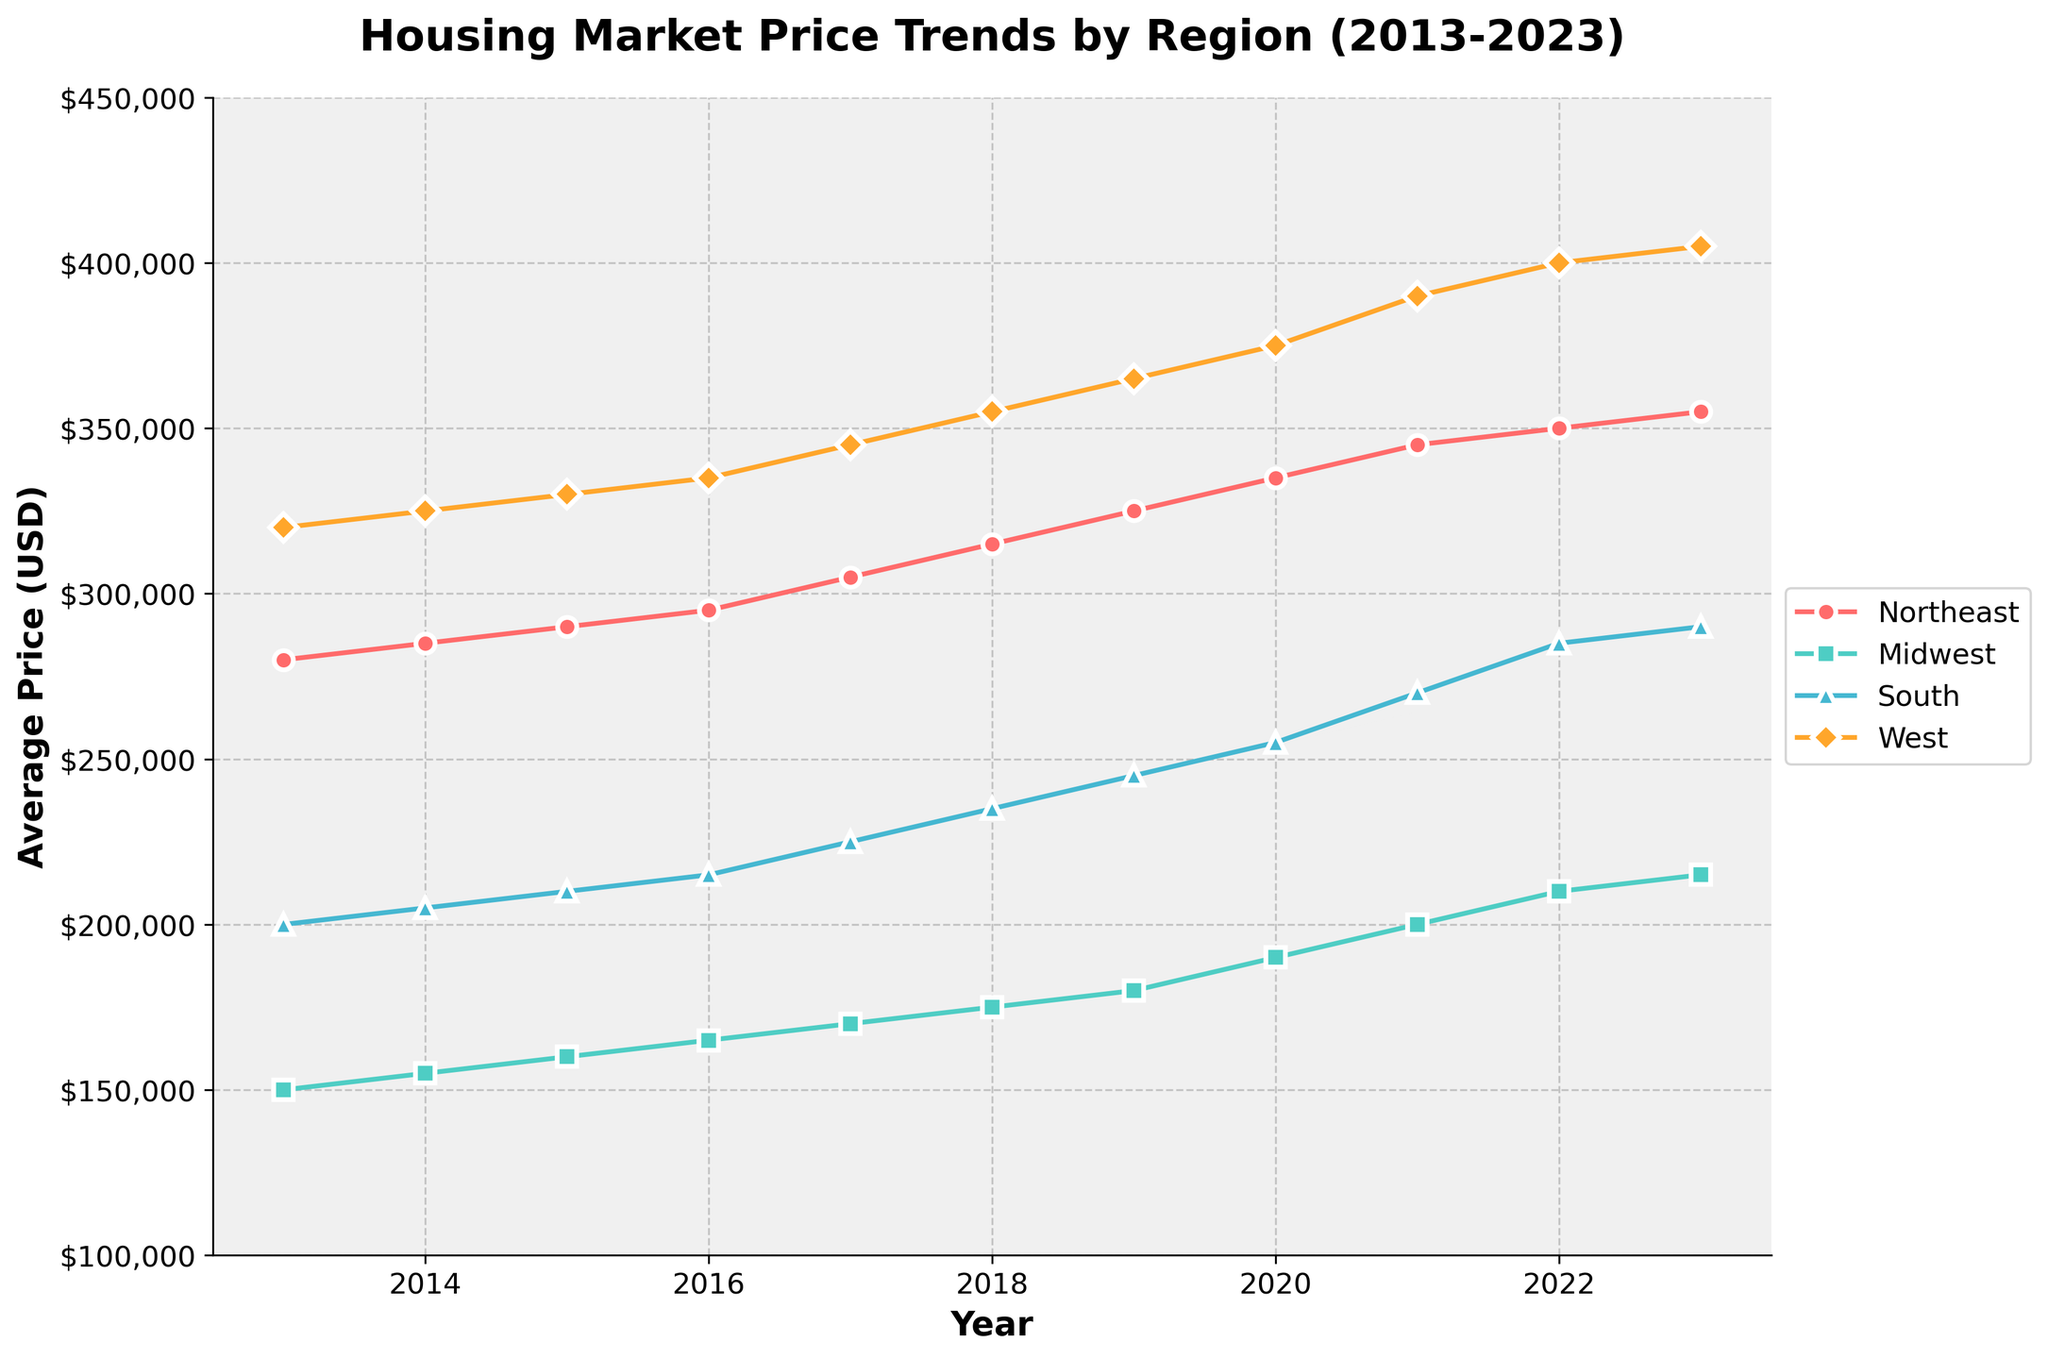What is the average house price in the Northeast for the year 2023? Locate the year 2023 on the x-axis, find the corresponding data point for the Northeast, and read the y-axis value. It is 355,000.
Answer: $355,000 What region had the highest average house price in 2020? Locate the year 2020 on the x-axis, compare the y-axis values of all regions, and identify that the West region had the highest average house price.
Answer: West How much did the average house price in the South increase from 2016 to 2023? Find the y-axis values for the South in 2016 and 2023, which are 215,000 and 290,000, respectively. Calculate the difference: 290,000 - 215,000 = 75,000.
Answer: $75,000 Which region showed the least price increase over the entire period from 2013 to 2023? Calculate the difference in average house prices for each region between 2013 and 2023, and compare these differences. The Midwest has the smallest increase (215,000 - 150,000 = 65,000).
Answer: Midwest What year did the Midwest region's average house price reach 200,000? Locate the Midwest region's trend line and find the year where the y-axis value corresponds to 200,000. It is in 2021.
Answer: 2021 Between the Northeast and the South, which region had a higher average house price in 2019? For the year 2019, compare the y-axis values for the Northeast and South regions. The Northeast had a higher average house price (325,000) compared to the South (245,000).
Answer: Northeast Which region has consistently shown an increasing trend over the last decade? Observe the general trend of each regional line. All regions show a consistent increase in average house prices, confirming an overall upward trend.
Answer: All regions What is the overall average house price for the West region from 2013 to 2023? Sum the West region’s average house prices for each year and divide by the number of years: (320,000 + 325,000 + 330,000 + 335,000 + 345,000 + 355,000 + 365,000 + 375,000 + 390,000 + 400,000 + 405,000)/11 = 361,818.18.
Answer: $361,818.18 Which year marked the largest one-year increase in the average house price for the Northeast region? Calculate the difference in average house prices year-over-year for the Northeast and identify the largest increase. The largest increase occurred from 2020 to 2021 (345,000 - 335,000 = 10,000).
Answer: 2021 How did the average price trend in the Midwest compare to the national average trend? Compare the Midwest line to the overall trend lines. All regions, including the Midwest, show increasing trends, indicating the Midwest had a similar increasing trend to the national pattern.
Answer: Increasing, similar to the national trend 